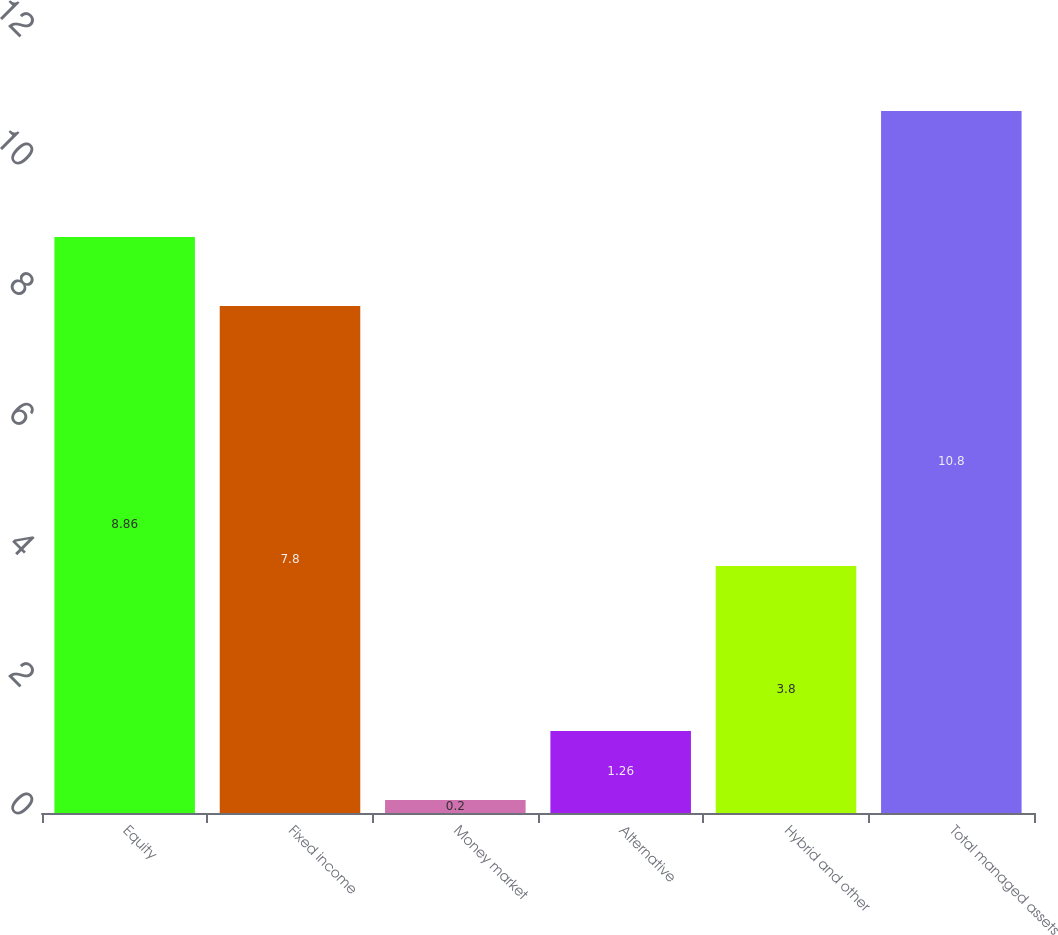Convert chart to OTSL. <chart><loc_0><loc_0><loc_500><loc_500><bar_chart><fcel>Equity<fcel>Fixed income<fcel>Money market<fcel>Alternative<fcel>Hybrid and other<fcel>Total managed assets<nl><fcel>8.86<fcel>7.8<fcel>0.2<fcel>1.26<fcel>3.8<fcel>10.8<nl></chart> 